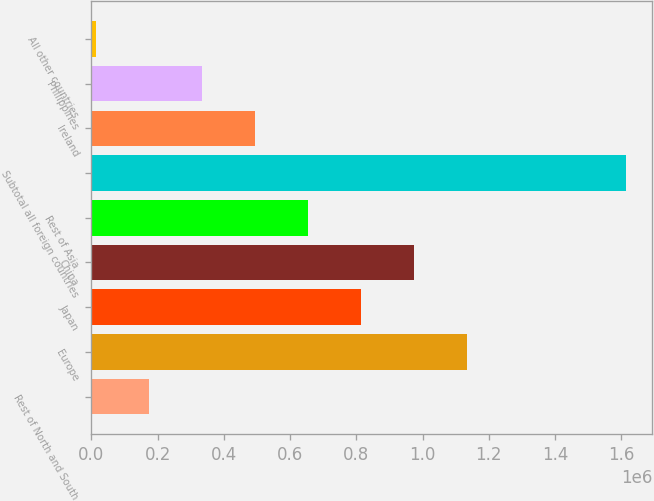Convert chart. <chart><loc_0><loc_0><loc_500><loc_500><bar_chart><fcel>Rest of North and South<fcel>Europe<fcel>Japan<fcel>China<fcel>Rest of Asia<fcel>Subtotal all foreign countries<fcel>Ireland<fcel>Philippines<fcel>All other countries<nl><fcel>173139<fcel>1.13325e+06<fcel>813210<fcel>973228<fcel>653193<fcel>1.6133e+06<fcel>493175<fcel>333157<fcel>13121<nl></chart> 